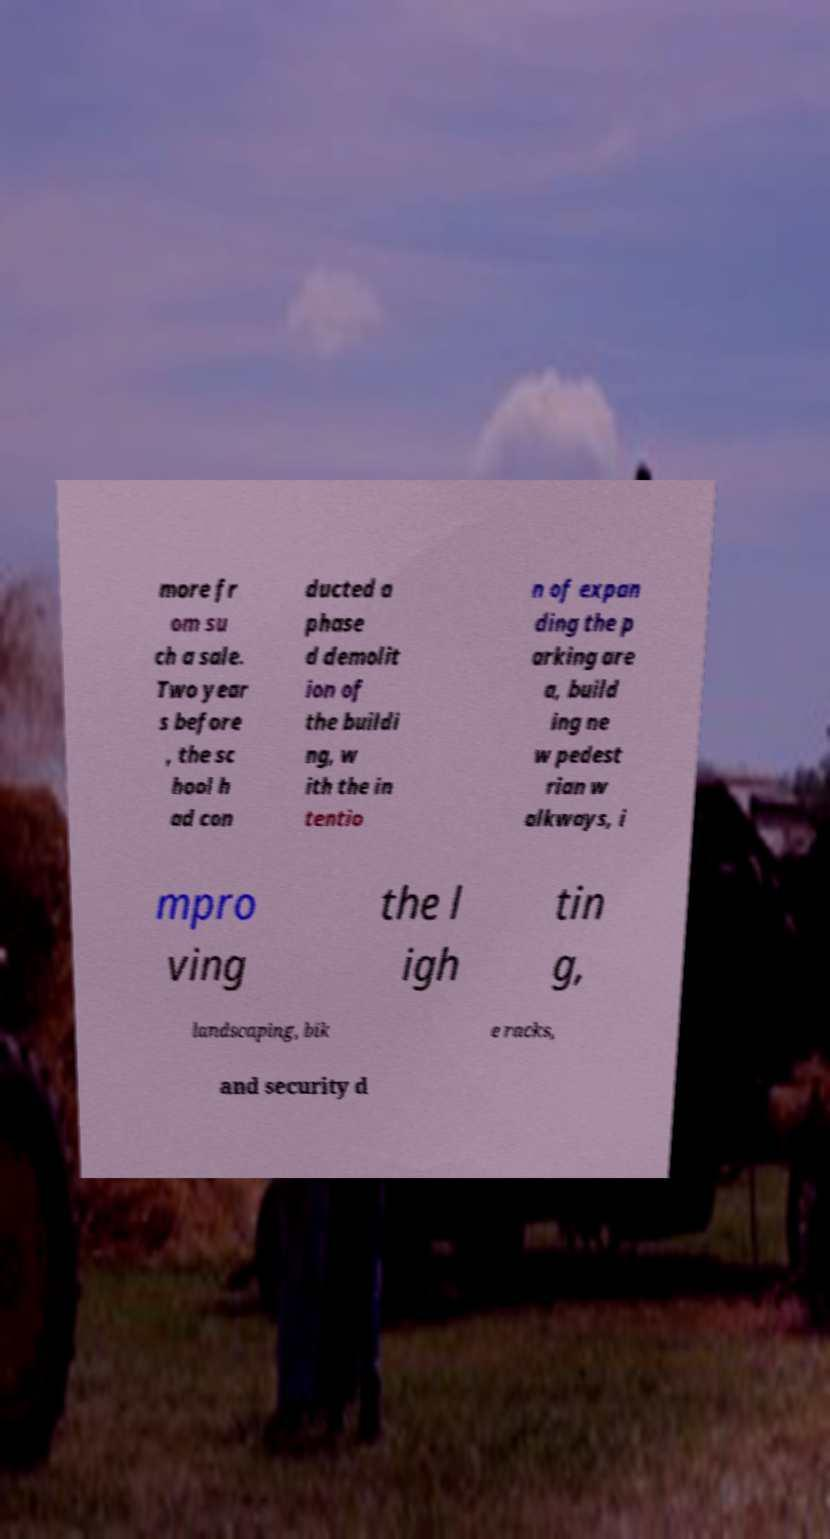Can you accurately transcribe the text from the provided image for me? more fr om su ch a sale. Two year s before , the sc hool h ad con ducted a phase d demolit ion of the buildi ng, w ith the in tentio n of expan ding the p arking are a, build ing ne w pedest rian w alkways, i mpro ving the l igh tin g, landscaping, bik e racks, and security d 